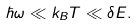Convert formula to latex. <formula><loc_0><loc_0><loc_500><loc_500>\hbar { \omega } \ll k _ { B } T \ll \delta E .</formula> 